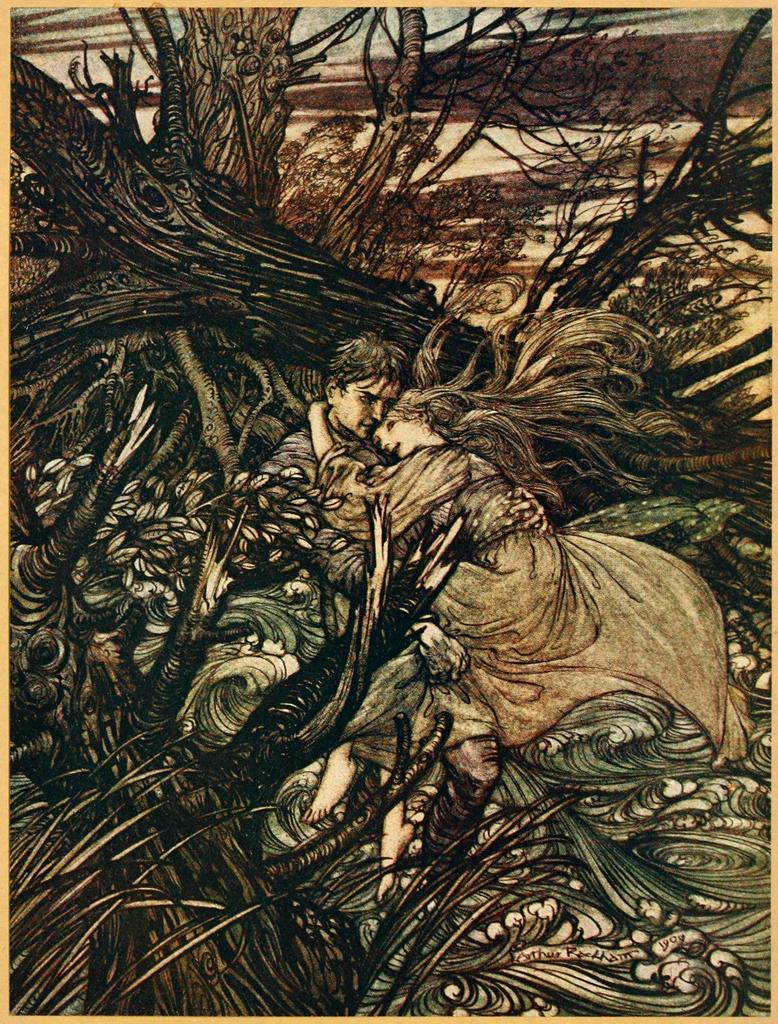Please provide a concise description of this image. This is a painting of a man and woman holding each other. Also there are trees. 